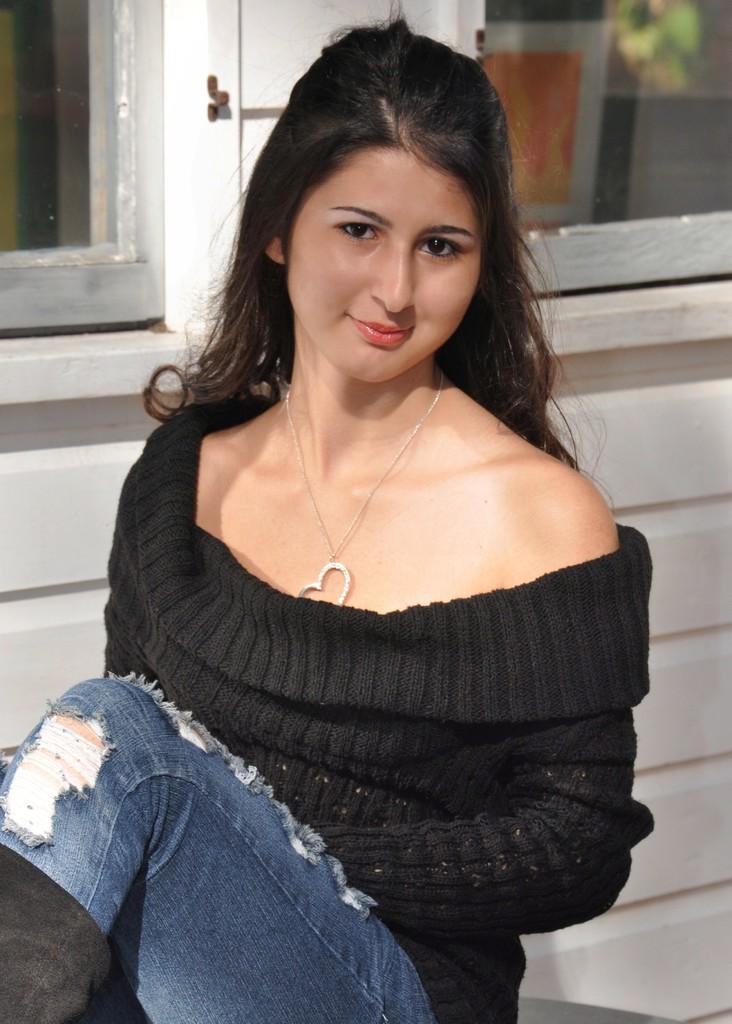Please provide a concise description of this image. In this image there is a lady, she is wearing black color top and blue color jeans, in the back ground there is a white wall and there are glasses. 